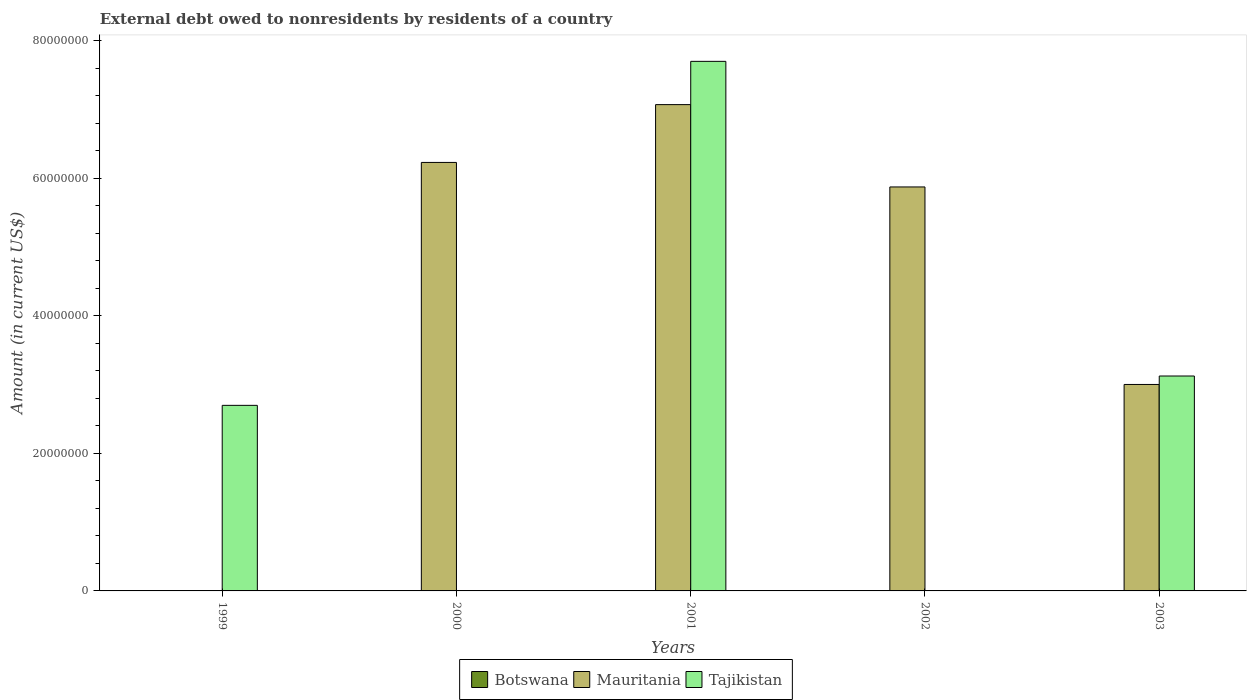How many bars are there on the 1st tick from the left?
Your answer should be very brief. 1. What is the label of the 4th group of bars from the left?
Your response must be concise. 2002. In how many cases, is the number of bars for a given year not equal to the number of legend labels?
Offer a very short reply. 5. Across all years, what is the maximum external debt owed by residents in Mauritania?
Your answer should be very brief. 7.07e+07. What is the total external debt owed by residents in Tajikistan in the graph?
Make the answer very short. 1.35e+08. What is the difference between the external debt owed by residents in Mauritania in 2002 and that in 2003?
Offer a very short reply. 2.87e+07. What is the average external debt owed by residents in Tajikistan per year?
Your answer should be very brief. 2.71e+07. In the year 2003, what is the difference between the external debt owed by residents in Mauritania and external debt owed by residents in Tajikistan?
Your answer should be compact. -1.23e+06. What is the ratio of the external debt owed by residents in Tajikistan in 1999 to that in 2001?
Your response must be concise. 0.35. Is the external debt owed by residents in Mauritania in 2002 less than that in 2003?
Your answer should be very brief. No. What is the difference between the highest and the second highest external debt owed by residents in Mauritania?
Offer a terse response. 8.41e+06. In how many years, is the external debt owed by residents in Mauritania greater than the average external debt owed by residents in Mauritania taken over all years?
Keep it short and to the point. 3. Is it the case that in every year, the sum of the external debt owed by residents in Mauritania and external debt owed by residents in Tajikistan is greater than the external debt owed by residents in Botswana?
Keep it short and to the point. Yes. Are the values on the major ticks of Y-axis written in scientific E-notation?
Ensure brevity in your answer.  No. Does the graph contain any zero values?
Your response must be concise. Yes. Does the graph contain grids?
Your answer should be very brief. No. How are the legend labels stacked?
Keep it short and to the point. Horizontal. What is the title of the graph?
Give a very brief answer. External debt owed to nonresidents by residents of a country. What is the label or title of the X-axis?
Provide a succinct answer. Years. What is the Amount (in current US$) of Botswana in 1999?
Make the answer very short. 0. What is the Amount (in current US$) in Tajikistan in 1999?
Make the answer very short. 2.70e+07. What is the Amount (in current US$) of Botswana in 2000?
Make the answer very short. 0. What is the Amount (in current US$) in Mauritania in 2000?
Your response must be concise. 6.23e+07. What is the Amount (in current US$) in Botswana in 2001?
Offer a very short reply. 0. What is the Amount (in current US$) of Mauritania in 2001?
Provide a succinct answer. 7.07e+07. What is the Amount (in current US$) in Tajikistan in 2001?
Ensure brevity in your answer.  7.70e+07. What is the Amount (in current US$) of Botswana in 2002?
Your answer should be compact. 0. What is the Amount (in current US$) in Mauritania in 2002?
Keep it short and to the point. 5.87e+07. What is the Amount (in current US$) of Tajikistan in 2002?
Make the answer very short. 0. What is the Amount (in current US$) in Botswana in 2003?
Keep it short and to the point. 0. What is the Amount (in current US$) in Mauritania in 2003?
Offer a terse response. 3.00e+07. What is the Amount (in current US$) of Tajikistan in 2003?
Ensure brevity in your answer.  3.13e+07. Across all years, what is the maximum Amount (in current US$) of Mauritania?
Your answer should be compact. 7.07e+07. Across all years, what is the maximum Amount (in current US$) in Tajikistan?
Your answer should be very brief. 7.70e+07. Across all years, what is the minimum Amount (in current US$) of Mauritania?
Your answer should be compact. 0. Across all years, what is the minimum Amount (in current US$) in Tajikistan?
Give a very brief answer. 0. What is the total Amount (in current US$) in Mauritania in the graph?
Offer a very short reply. 2.22e+08. What is the total Amount (in current US$) in Tajikistan in the graph?
Your answer should be compact. 1.35e+08. What is the difference between the Amount (in current US$) of Tajikistan in 1999 and that in 2001?
Give a very brief answer. -5.00e+07. What is the difference between the Amount (in current US$) of Tajikistan in 1999 and that in 2003?
Keep it short and to the point. -4.27e+06. What is the difference between the Amount (in current US$) of Mauritania in 2000 and that in 2001?
Offer a very short reply. -8.41e+06. What is the difference between the Amount (in current US$) in Mauritania in 2000 and that in 2002?
Make the answer very short. 3.57e+06. What is the difference between the Amount (in current US$) of Mauritania in 2000 and that in 2003?
Offer a very short reply. 3.23e+07. What is the difference between the Amount (in current US$) of Mauritania in 2001 and that in 2002?
Ensure brevity in your answer.  1.20e+07. What is the difference between the Amount (in current US$) in Mauritania in 2001 and that in 2003?
Keep it short and to the point. 4.07e+07. What is the difference between the Amount (in current US$) in Tajikistan in 2001 and that in 2003?
Offer a very short reply. 4.58e+07. What is the difference between the Amount (in current US$) in Mauritania in 2002 and that in 2003?
Provide a short and direct response. 2.87e+07. What is the difference between the Amount (in current US$) of Mauritania in 2000 and the Amount (in current US$) of Tajikistan in 2001?
Your answer should be compact. -1.47e+07. What is the difference between the Amount (in current US$) in Mauritania in 2000 and the Amount (in current US$) in Tajikistan in 2003?
Offer a very short reply. 3.11e+07. What is the difference between the Amount (in current US$) in Mauritania in 2001 and the Amount (in current US$) in Tajikistan in 2003?
Your answer should be compact. 3.95e+07. What is the difference between the Amount (in current US$) in Mauritania in 2002 and the Amount (in current US$) in Tajikistan in 2003?
Offer a very short reply. 2.75e+07. What is the average Amount (in current US$) in Botswana per year?
Offer a terse response. 0. What is the average Amount (in current US$) in Mauritania per year?
Offer a terse response. 4.44e+07. What is the average Amount (in current US$) in Tajikistan per year?
Provide a succinct answer. 2.71e+07. In the year 2001, what is the difference between the Amount (in current US$) in Mauritania and Amount (in current US$) in Tajikistan?
Provide a succinct answer. -6.29e+06. In the year 2003, what is the difference between the Amount (in current US$) of Mauritania and Amount (in current US$) of Tajikistan?
Offer a terse response. -1.23e+06. What is the ratio of the Amount (in current US$) of Tajikistan in 1999 to that in 2001?
Your answer should be compact. 0.35. What is the ratio of the Amount (in current US$) of Tajikistan in 1999 to that in 2003?
Provide a short and direct response. 0.86. What is the ratio of the Amount (in current US$) in Mauritania in 2000 to that in 2001?
Provide a short and direct response. 0.88. What is the ratio of the Amount (in current US$) of Mauritania in 2000 to that in 2002?
Your answer should be compact. 1.06. What is the ratio of the Amount (in current US$) in Mauritania in 2000 to that in 2003?
Ensure brevity in your answer.  2.08. What is the ratio of the Amount (in current US$) in Mauritania in 2001 to that in 2002?
Your answer should be compact. 1.2. What is the ratio of the Amount (in current US$) in Mauritania in 2001 to that in 2003?
Offer a very short reply. 2.36. What is the ratio of the Amount (in current US$) of Tajikistan in 2001 to that in 2003?
Keep it short and to the point. 2.46. What is the ratio of the Amount (in current US$) of Mauritania in 2002 to that in 2003?
Make the answer very short. 1.96. What is the difference between the highest and the second highest Amount (in current US$) in Mauritania?
Give a very brief answer. 8.41e+06. What is the difference between the highest and the second highest Amount (in current US$) of Tajikistan?
Provide a succinct answer. 4.58e+07. What is the difference between the highest and the lowest Amount (in current US$) in Mauritania?
Your answer should be very brief. 7.07e+07. What is the difference between the highest and the lowest Amount (in current US$) of Tajikistan?
Keep it short and to the point. 7.70e+07. 